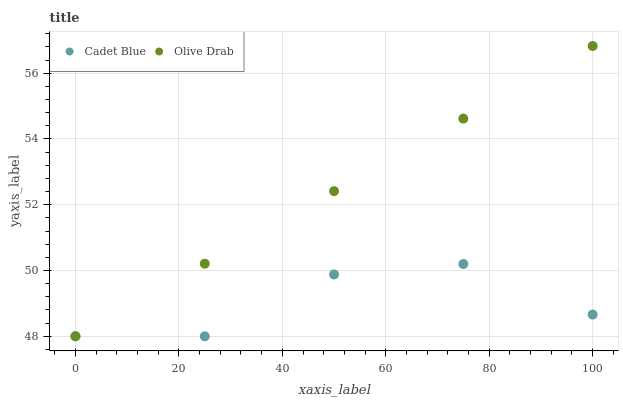Does Cadet Blue have the minimum area under the curve?
Answer yes or no. Yes. Does Olive Drab have the maximum area under the curve?
Answer yes or no. Yes. Does Olive Drab have the minimum area under the curve?
Answer yes or no. No. Is Olive Drab the smoothest?
Answer yes or no. Yes. Is Cadet Blue the roughest?
Answer yes or no. Yes. Is Olive Drab the roughest?
Answer yes or no. No. Does Cadet Blue have the lowest value?
Answer yes or no. Yes. Does Olive Drab have the highest value?
Answer yes or no. Yes. Does Cadet Blue intersect Olive Drab?
Answer yes or no. Yes. Is Cadet Blue less than Olive Drab?
Answer yes or no. No. Is Cadet Blue greater than Olive Drab?
Answer yes or no. No. 